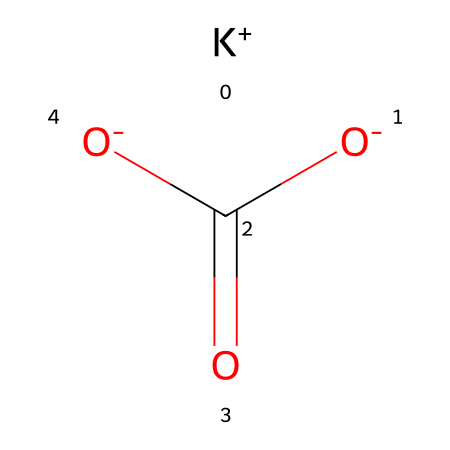What is the molecular formula for potassium bicarbonate? The SMILES representation indicates the presence of potassium (K), carbon (C), and oxygen (O) in the compound. Counting the elements gives us K, C, 3 O (from the two oxygen in bicarbonate plus one for the carbon). Therefore, the molecular formula can be formulated as KHC(=O)2.
Answer: KHC(=O)2 How many total atoms are present in potassium bicarbonate? The SMILES structure reveals 1 potassium atom, 1 carbon atom, 3 oxygen atoms, and 1 hydrogen atom from the bicarbonate part. Adding these gives a total of 6 atoms.
Answer: 6 What type of chemical is potassium bicarbonate? The structure displays a potassium ion (K+) combined with bicarbonate (HCO3-), indicating it is a salt as it consists of anions and cations. Specifically, it is a bicarbonate salt due to its formation from bicarbonate.
Answer: salt What role does potassium bicarbonate play as an electrolyte? Potassium bicarbonate dissociates into potassium ions (K+) and bicarbonate ions (HCO3-) in solution, providing essential ions that help maintain fluid balance and nerve function, which is crucial during endurance activities such as ultra marathons.
Answer: maintains fluid balance How many oxygen atoms are in the bicarbonate ion of potassium bicarbonate? The visual breakdown of the compound shows that bicarbonate (HCO3-) is included. The formula of bicarbonate comprises 3 oxygen atoms.
Answer: 3 Is potassium bicarbonate acidic, basic, or neutral? Bicarbonate (HCO3-) can act as either a weak acid or a weak base in solution, but overall, in its nature and common usage, it is considered to have neutral properties when combined with potassium cation.
Answer: neutral 